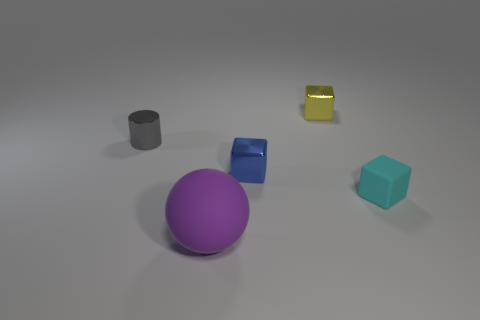Subtract all small metal blocks. How many blocks are left? 1 Add 2 brown spheres. How many objects exist? 7 Subtract all yellow blocks. How many blocks are left? 2 Subtract 1 spheres. How many spheres are left? 0 Subtract all spheres. How many objects are left? 4 Subtract all cyan cylinders. Subtract all yellow spheres. How many cylinders are left? 1 Subtract all yellow cubes. How many yellow balls are left? 0 Subtract all small matte things. Subtract all blue metal cubes. How many objects are left? 3 Add 1 gray objects. How many gray objects are left? 2 Add 5 purple metal spheres. How many purple metal spheres exist? 5 